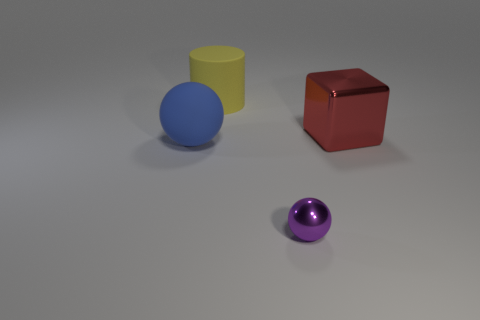Do the yellow object and the large blue object have the same shape?
Your response must be concise. No. How many things are either big matte objects that are behind the red thing or objects on the right side of the cylinder?
Offer a terse response. 3. What number of things are either tiny purple objects or cyan things?
Keep it short and to the point. 1. There is a large thing behind the red object; what number of large blocks are behind it?
Your answer should be compact. 0. How many other things are there of the same size as the red metal cube?
Your answer should be compact. 2. There is a rubber thing in front of the yellow rubber cylinder; is its shape the same as the tiny object?
Provide a short and direct response. Yes. What is the material of the sphere right of the cylinder?
Provide a succinct answer. Metal. Are there any red cubes made of the same material as the purple object?
Give a very brief answer. Yes. The purple metal ball has what size?
Your response must be concise. Small. How many cyan things are either large rubber cubes or large spheres?
Your answer should be very brief. 0. 